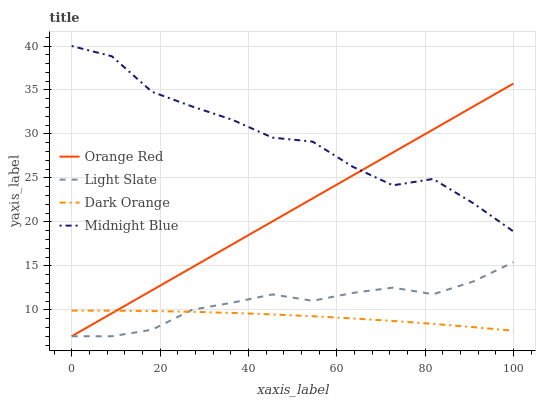Does Dark Orange have the minimum area under the curve?
Answer yes or no. Yes. Does Midnight Blue have the maximum area under the curve?
Answer yes or no. Yes. Does Orange Red have the minimum area under the curve?
Answer yes or no. No. Does Orange Red have the maximum area under the curve?
Answer yes or no. No. Is Orange Red the smoothest?
Answer yes or no. Yes. Is Midnight Blue the roughest?
Answer yes or no. Yes. Is Dark Orange the smoothest?
Answer yes or no. No. Is Dark Orange the roughest?
Answer yes or no. No. Does Dark Orange have the lowest value?
Answer yes or no. No. Does Midnight Blue have the highest value?
Answer yes or no. Yes. Does Orange Red have the highest value?
Answer yes or no. No. Is Dark Orange less than Midnight Blue?
Answer yes or no. Yes. Is Midnight Blue greater than Dark Orange?
Answer yes or no. Yes. Does Midnight Blue intersect Orange Red?
Answer yes or no. Yes. Is Midnight Blue less than Orange Red?
Answer yes or no. No. Is Midnight Blue greater than Orange Red?
Answer yes or no. No. Does Dark Orange intersect Midnight Blue?
Answer yes or no. No. 